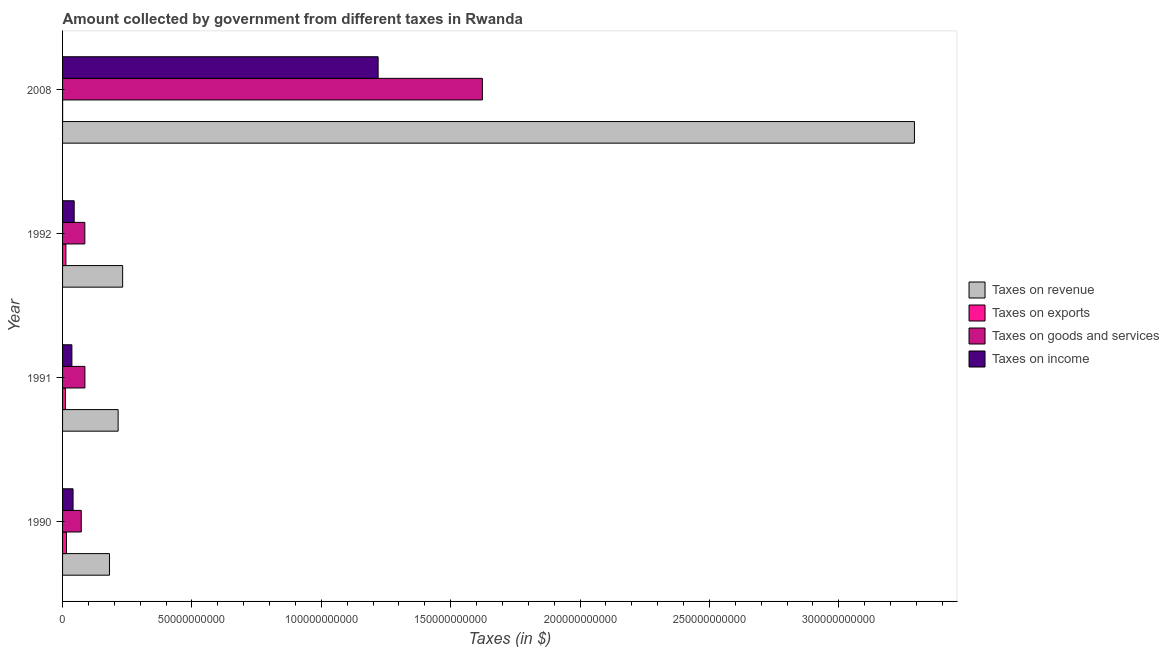Are the number of bars per tick equal to the number of legend labels?
Offer a very short reply. Yes. How many bars are there on the 4th tick from the top?
Offer a terse response. 4. In how many cases, is the number of bars for a given year not equal to the number of legend labels?
Give a very brief answer. 0. What is the amount collected as tax on income in 2008?
Make the answer very short. 1.22e+11. Across all years, what is the maximum amount collected as tax on exports?
Provide a succinct answer. 1.51e+09. Across all years, what is the minimum amount collected as tax on goods?
Give a very brief answer. 7.23e+09. What is the total amount collected as tax on exports in the graph?
Make the answer very short. 3.92e+09. What is the difference between the amount collected as tax on goods in 1991 and that in 2008?
Ensure brevity in your answer.  -1.54e+11. What is the difference between the amount collected as tax on revenue in 1991 and the amount collected as tax on goods in 2008?
Offer a very short reply. -1.41e+11. What is the average amount collected as tax on goods per year?
Ensure brevity in your answer.  4.67e+1. In the year 1991, what is the difference between the amount collected as tax on goods and amount collected as tax on income?
Provide a short and direct response. 5.03e+09. What is the ratio of the amount collected as tax on revenue in 1992 to that in 2008?
Provide a short and direct response. 0.07. Is the amount collected as tax on income in 1991 less than that in 1992?
Your response must be concise. Yes. What is the difference between the highest and the second highest amount collected as tax on exports?
Keep it short and to the point. 2.14e+08. What is the difference between the highest and the lowest amount collected as tax on exports?
Offer a terse response. 1.49e+09. Is the sum of the amount collected as tax on revenue in 1991 and 1992 greater than the maximum amount collected as tax on exports across all years?
Your response must be concise. Yes. What does the 2nd bar from the top in 2008 represents?
Ensure brevity in your answer.  Taxes on goods and services. What does the 3rd bar from the bottom in 1992 represents?
Your answer should be very brief. Taxes on goods and services. Is it the case that in every year, the sum of the amount collected as tax on revenue and amount collected as tax on exports is greater than the amount collected as tax on goods?
Keep it short and to the point. Yes. How many bars are there?
Provide a short and direct response. 16. What is the difference between two consecutive major ticks on the X-axis?
Provide a short and direct response. 5.00e+1. Are the values on the major ticks of X-axis written in scientific E-notation?
Provide a short and direct response. No. Does the graph contain any zero values?
Provide a succinct answer. No. How are the legend labels stacked?
Offer a terse response. Vertical. What is the title of the graph?
Offer a terse response. Amount collected by government from different taxes in Rwanda. Does "Grants and Revenue" appear as one of the legend labels in the graph?
Make the answer very short. No. What is the label or title of the X-axis?
Provide a succinct answer. Taxes (in $). What is the label or title of the Y-axis?
Ensure brevity in your answer.  Year. What is the Taxes (in $) of Taxes on revenue in 1990?
Provide a short and direct response. 1.81e+1. What is the Taxes (in $) in Taxes on exports in 1990?
Give a very brief answer. 1.51e+09. What is the Taxes (in $) in Taxes on goods and services in 1990?
Provide a short and direct response. 7.23e+09. What is the Taxes (in $) of Taxes on income in 1990?
Provide a succinct answer. 4.06e+09. What is the Taxes (in $) of Taxes on revenue in 1991?
Your answer should be very brief. 2.15e+1. What is the Taxes (in $) of Taxes on exports in 1991?
Provide a short and direct response. 1.11e+09. What is the Taxes (in $) in Taxes on goods and services in 1991?
Keep it short and to the point. 8.63e+09. What is the Taxes (in $) in Taxes on income in 1991?
Your answer should be very brief. 3.60e+09. What is the Taxes (in $) in Taxes on revenue in 1992?
Give a very brief answer. 2.32e+1. What is the Taxes (in $) in Taxes on exports in 1992?
Your answer should be compact. 1.29e+09. What is the Taxes (in $) in Taxes on goods and services in 1992?
Your answer should be very brief. 8.60e+09. What is the Taxes (in $) of Taxes on income in 1992?
Your response must be concise. 4.49e+09. What is the Taxes (in $) in Taxes on revenue in 2008?
Keep it short and to the point. 3.29e+11. What is the Taxes (in $) in Taxes on exports in 2008?
Give a very brief answer. 1.73e+07. What is the Taxes (in $) of Taxes on goods and services in 2008?
Your response must be concise. 1.62e+11. What is the Taxes (in $) of Taxes on income in 2008?
Provide a succinct answer. 1.22e+11. Across all years, what is the maximum Taxes (in $) of Taxes on revenue?
Provide a succinct answer. 3.29e+11. Across all years, what is the maximum Taxes (in $) of Taxes on exports?
Provide a succinct answer. 1.51e+09. Across all years, what is the maximum Taxes (in $) in Taxes on goods and services?
Keep it short and to the point. 1.62e+11. Across all years, what is the maximum Taxes (in $) in Taxes on income?
Offer a terse response. 1.22e+11. Across all years, what is the minimum Taxes (in $) in Taxes on revenue?
Your answer should be compact. 1.81e+1. Across all years, what is the minimum Taxes (in $) in Taxes on exports?
Ensure brevity in your answer.  1.73e+07. Across all years, what is the minimum Taxes (in $) of Taxes on goods and services?
Keep it short and to the point. 7.23e+09. Across all years, what is the minimum Taxes (in $) of Taxes on income?
Offer a very short reply. 3.60e+09. What is the total Taxes (in $) in Taxes on revenue in the graph?
Your answer should be compact. 3.92e+11. What is the total Taxes (in $) of Taxes on exports in the graph?
Offer a terse response. 3.92e+09. What is the total Taxes (in $) in Taxes on goods and services in the graph?
Make the answer very short. 1.87e+11. What is the total Taxes (in $) of Taxes on income in the graph?
Offer a terse response. 1.34e+11. What is the difference between the Taxes (in $) in Taxes on revenue in 1990 and that in 1991?
Your answer should be very brief. -3.34e+09. What is the difference between the Taxes (in $) in Taxes on exports in 1990 and that in 1991?
Offer a very short reply. 3.99e+08. What is the difference between the Taxes (in $) in Taxes on goods and services in 1990 and that in 1991?
Make the answer very short. -1.40e+09. What is the difference between the Taxes (in $) of Taxes on income in 1990 and that in 1991?
Offer a very short reply. 4.54e+08. What is the difference between the Taxes (in $) in Taxes on revenue in 1990 and that in 1992?
Provide a short and direct response. -5.09e+09. What is the difference between the Taxes (in $) in Taxes on exports in 1990 and that in 1992?
Offer a terse response. 2.14e+08. What is the difference between the Taxes (in $) in Taxes on goods and services in 1990 and that in 1992?
Provide a succinct answer. -1.38e+09. What is the difference between the Taxes (in $) of Taxes on income in 1990 and that in 1992?
Your answer should be compact. -4.31e+08. What is the difference between the Taxes (in $) of Taxes on revenue in 1990 and that in 2008?
Give a very brief answer. -3.11e+11. What is the difference between the Taxes (in $) in Taxes on exports in 1990 and that in 2008?
Your answer should be very brief. 1.49e+09. What is the difference between the Taxes (in $) of Taxes on goods and services in 1990 and that in 2008?
Offer a terse response. -1.55e+11. What is the difference between the Taxes (in $) in Taxes on income in 1990 and that in 2008?
Make the answer very short. -1.18e+11. What is the difference between the Taxes (in $) in Taxes on revenue in 1991 and that in 1992?
Your answer should be very brief. -1.75e+09. What is the difference between the Taxes (in $) in Taxes on exports in 1991 and that in 1992?
Your answer should be compact. -1.85e+08. What is the difference between the Taxes (in $) of Taxes on goods and services in 1991 and that in 1992?
Make the answer very short. 2.90e+07. What is the difference between the Taxes (in $) in Taxes on income in 1991 and that in 1992?
Make the answer very short. -8.85e+08. What is the difference between the Taxes (in $) in Taxes on revenue in 1991 and that in 2008?
Provide a short and direct response. -3.08e+11. What is the difference between the Taxes (in $) in Taxes on exports in 1991 and that in 2008?
Provide a succinct answer. 1.09e+09. What is the difference between the Taxes (in $) in Taxes on goods and services in 1991 and that in 2008?
Make the answer very short. -1.54e+11. What is the difference between the Taxes (in $) of Taxes on income in 1991 and that in 2008?
Ensure brevity in your answer.  -1.18e+11. What is the difference between the Taxes (in $) in Taxes on revenue in 1992 and that in 2008?
Ensure brevity in your answer.  -3.06e+11. What is the difference between the Taxes (in $) in Taxes on exports in 1992 and that in 2008?
Ensure brevity in your answer.  1.27e+09. What is the difference between the Taxes (in $) of Taxes on goods and services in 1992 and that in 2008?
Keep it short and to the point. -1.54e+11. What is the difference between the Taxes (in $) in Taxes on income in 1992 and that in 2008?
Keep it short and to the point. -1.17e+11. What is the difference between the Taxes (in $) of Taxes on revenue in 1990 and the Taxes (in $) of Taxes on exports in 1991?
Your answer should be compact. 1.70e+1. What is the difference between the Taxes (in $) in Taxes on revenue in 1990 and the Taxes (in $) in Taxes on goods and services in 1991?
Your response must be concise. 9.50e+09. What is the difference between the Taxes (in $) in Taxes on revenue in 1990 and the Taxes (in $) in Taxes on income in 1991?
Ensure brevity in your answer.  1.45e+1. What is the difference between the Taxes (in $) in Taxes on exports in 1990 and the Taxes (in $) in Taxes on goods and services in 1991?
Your answer should be very brief. -7.13e+09. What is the difference between the Taxes (in $) in Taxes on exports in 1990 and the Taxes (in $) in Taxes on income in 1991?
Your answer should be very brief. -2.10e+09. What is the difference between the Taxes (in $) of Taxes on goods and services in 1990 and the Taxes (in $) of Taxes on income in 1991?
Provide a succinct answer. 3.63e+09. What is the difference between the Taxes (in $) of Taxes on revenue in 1990 and the Taxes (in $) of Taxes on exports in 1992?
Make the answer very short. 1.68e+1. What is the difference between the Taxes (in $) of Taxes on revenue in 1990 and the Taxes (in $) of Taxes on goods and services in 1992?
Provide a succinct answer. 9.52e+09. What is the difference between the Taxes (in $) of Taxes on revenue in 1990 and the Taxes (in $) of Taxes on income in 1992?
Your answer should be very brief. 1.36e+1. What is the difference between the Taxes (in $) of Taxes on exports in 1990 and the Taxes (in $) of Taxes on goods and services in 1992?
Give a very brief answer. -7.10e+09. What is the difference between the Taxes (in $) in Taxes on exports in 1990 and the Taxes (in $) in Taxes on income in 1992?
Your answer should be very brief. -2.98e+09. What is the difference between the Taxes (in $) of Taxes on goods and services in 1990 and the Taxes (in $) of Taxes on income in 1992?
Keep it short and to the point. 2.74e+09. What is the difference between the Taxes (in $) in Taxes on revenue in 1990 and the Taxes (in $) in Taxes on exports in 2008?
Ensure brevity in your answer.  1.81e+1. What is the difference between the Taxes (in $) in Taxes on revenue in 1990 and the Taxes (in $) in Taxes on goods and services in 2008?
Provide a succinct answer. -1.44e+11. What is the difference between the Taxes (in $) of Taxes on revenue in 1990 and the Taxes (in $) of Taxes on income in 2008?
Provide a short and direct response. -1.04e+11. What is the difference between the Taxes (in $) of Taxes on exports in 1990 and the Taxes (in $) of Taxes on goods and services in 2008?
Keep it short and to the point. -1.61e+11. What is the difference between the Taxes (in $) of Taxes on exports in 1990 and the Taxes (in $) of Taxes on income in 2008?
Ensure brevity in your answer.  -1.20e+11. What is the difference between the Taxes (in $) in Taxes on goods and services in 1990 and the Taxes (in $) in Taxes on income in 2008?
Keep it short and to the point. -1.15e+11. What is the difference between the Taxes (in $) in Taxes on revenue in 1991 and the Taxes (in $) in Taxes on exports in 1992?
Your answer should be compact. 2.02e+1. What is the difference between the Taxes (in $) in Taxes on revenue in 1991 and the Taxes (in $) in Taxes on goods and services in 1992?
Make the answer very short. 1.29e+1. What is the difference between the Taxes (in $) of Taxes on revenue in 1991 and the Taxes (in $) of Taxes on income in 1992?
Offer a terse response. 1.70e+1. What is the difference between the Taxes (in $) of Taxes on exports in 1991 and the Taxes (in $) of Taxes on goods and services in 1992?
Your answer should be compact. -7.50e+09. What is the difference between the Taxes (in $) in Taxes on exports in 1991 and the Taxes (in $) in Taxes on income in 1992?
Keep it short and to the point. -3.38e+09. What is the difference between the Taxes (in $) in Taxes on goods and services in 1991 and the Taxes (in $) in Taxes on income in 1992?
Offer a very short reply. 4.14e+09. What is the difference between the Taxes (in $) of Taxes on revenue in 1991 and the Taxes (in $) of Taxes on exports in 2008?
Your answer should be very brief. 2.15e+1. What is the difference between the Taxes (in $) in Taxes on revenue in 1991 and the Taxes (in $) in Taxes on goods and services in 2008?
Offer a very short reply. -1.41e+11. What is the difference between the Taxes (in $) in Taxes on revenue in 1991 and the Taxes (in $) in Taxes on income in 2008?
Ensure brevity in your answer.  -1.00e+11. What is the difference between the Taxes (in $) in Taxes on exports in 1991 and the Taxes (in $) in Taxes on goods and services in 2008?
Keep it short and to the point. -1.61e+11. What is the difference between the Taxes (in $) of Taxes on exports in 1991 and the Taxes (in $) of Taxes on income in 2008?
Make the answer very short. -1.21e+11. What is the difference between the Taxes (in $) of Taxes on goods and services in 1991 and the Taxes (in $) of Taxes on income in 2008?
Keep it short and to the point. -1.13e+11. What is the difference between the Taxes (in $) in Taxes on revenue in 1992 and the Taxes (in $) in Taxes on exports in 2008?
Ensure brevity in your answer.  2.32e+1. What is the difference between the Taxes (in $) of Taxes on revenue in 1992 and the Taxes (in $) of Taxes on goods and services in 2008?
Offer a very short reply. -1.39e+11. What is the difference between the Taxes (in $) in Taxes on revenue in 1992 and the Taxes (in $) in Taxes on income in 2008?
Offer a terse response. -9.87e+1. What is the difference between the Taxes (in $) of Taxes on exports in 1992 and the Taxes (in $) of Taxes on goods and services in 2008?
Offer a very short reply. -1.61e+11. What is the difference between the Taxes (in $) of Taxes on exports in 1992 and the Taxes (in $) of Taxes on income in 2008?
Keep it short and to the point. -1.21e+11. What is the difference between the Taxes (in $) in Taxes on goods and services in 1992 and the Taxes (in $) in Taxes on income in 2008?
Provide a succinct answer. -1.13e+11. What is the average Taxes (in $) of Taxes on revenue per year?
Your answer should be very brief. 9.80e+1. What is the average Taxes (in $) of Taxes on exports per year?
Offer a terse response. 9.81e+08. What is the average Taxes (in $) in Taxes on goods and services per year?
Keep it short and to the point. 4.67e+1. What is the average Taxes (in $) in Taxes on income per year?
Keep it short and to the point. 3.35e+1. In the year 1990, what is the difference between the Taxes (in $) of Taxes on revenue and Taxes (in $) of Taxes on exports?
Give a very brief answer. 1.66e+1. In the year 1990, what is the difference between the Taxes (in $) in Taxes on revenue and Taxes (in $) in Taxes on goods and services?
Your answer should be very brief. 1.09e+1. In the year 1990, what is the difference between the Taxes (in $) in Taxes on revenue and Taxes (in $) in Taxes on income?
Provide a succinct answer. 1.41e+1. In the year 1990, what is the difference between the Taxes (in $) of Taxes on exports and Taxes (in $) of Taxes on goods and services?
Keep it short and to the point. -5.72e+09. In the year 1990, what is the difference between the Taxes (in $) in Taxes on exports and Taxes (in $) in Taxes on income?
Provide a succinct answer. -2.55e+09. In the year 1990, what is the difference between the Taxes (in $) in Taxes on goods and services and Taxes (in $) in Taxes on income?
Provide a succinct answer. 3.17e+09. In the year 1991, what is the difference between the Taxes (in $) of Taxes on revenue and Taxes (in $) of Taxes on exports?
Offer a very short reply. 2.04e+1. In the year 1991, what is the difference between the Taxes (in $) of Taxes on revenue and Taxes (in $) of Taxes on goods and services?
Provide a succinct answer. 1.28e+1. In the year 1991, what is the difference between the Taxes (in $) in Taxes on revenue and Taxes (in $) in Taxes on income?
Keep it short and to the point. 1.79e+1. In the year 1991, what is the difference between the Taxes (in $) of Taxes on exports and Taxes (in $) of Taxes on goods and services?
Offer a very short reply. -7.52e+09. In the year 1991, what is the difference between the Taxes (in $) of Taxes on exports and Taxes (in $) of Taxes on income?
Offer a very short reply. -2.50e+09. In the year 1991, what is the difference between the Taxes (in $) in Taxes on goods and services and Taxes (in $) in Taxes on income?
Offer a very short reply. 5.03e+09. In the year 1992, what is the difference between the Taxes (in $) in Taxes on revenue and Taxes (in $) in Taxes on exports?
Make the answer very short. 2.19e+1. In the year 1992, what is the difference between the Taxes (in $) in Taxes on revenue and Taxes (in $) in Taxes on goods and services?
Offer a very short reply. 1.46e+1. In the year 1992, what is the difference between the Taxes (in $) in Taxes on revenue and Taxes (in $) in Taxes on income?
Make the answer very short. 1.87e+1. In the year 1992, what is the difference between the Taxes (in $) of Taxes on exports and Taxes (in $) of Taxes on goods and services?
Offer a terse response. -7.31e+09. In the year 1992, what is the difference between the Taxes (in $) of Taxes on exports and Taxes (in $) of Taxes on income?
Make the answer very short. -3.20e+09. In the year 1992, what is the difference between the Taxes (in $) in Taxes on goods and services and Taxes (in $) in Taxes on income?
Provide a short and direct response. 4.12e+09. In the year 2008, what is the difference between the Taxes (in $) in Taxes on revenue and Taxes (in $) in Taxes on exports?
Offer a very short reply. 3.29e+11. In the year 2008, what is the difference between the Taxes (in $) of Taxes on revenue and Taxes (in $) of Taxes on goods and services?
Ensure brevity in your answer.  1.67e+11. In the year 2008, what is the difference between the Taxes (in $) of Taxes on revenue and Taxes (in $) of Taxes on income?
Give a very brief answer. 2.07e+11. In the year 2008, what is the difference between the Taxes (in $) of Taxes on exports and Taxes (in $) of Taxes on goods and services?
Your answer should be very brief. -1.62e+11. In the year 2008, what is the difference between the Taxes (in $) in Taxes on exports and Taxes (in $) in Taxes on income?
Offer a very short reply. -1.22e+11. In the year 2008, what is the difference between the Taxes (in $) of Taxes on goods and services and Taxes (in $) of Taxes on income?
Give a very brief answer. 4.03e+1. What is the ratio of the Taxes (in $) in Taxes on revenue in 1990 to that in 1991?
Keep it short and to the point. 0.84. What is the ratio of the Taxes (in $) in Taxes on exports in 1990 to that in 1991?
Keep it short and to the point. 1.36. What is the ratio of the Taxes (in $) in Taxes on goods and services in 1990 to that in 1991?
Make the answer very short. 0.84. What is the ratio of the Taxes (in $) in Taxes on income in 1990 to that in 1991?
Make the answer very short. 1.13. What is the ratio of the Taxes (in $) in Taxes on revenue in 1990 to that in 1992?
Make the answer very short. 0.78. What is the ratio of the Taxes (in $) of Taxes on exports in 1990 to that in 1992?
Your answer should be very brief. 1.17. What is the ratio of the Taxes (in $) in Taxes on goods and services in 1990 to that in 1992?
Provide a short and direct response. 0.84. What is the ratio of the Taxes (in $) of Taxes on income in 1990 to that in 1992?
Your response must be concise. 0.9. What is the ratio of the Taxes (in $) in Taxes on revenue in 1990 to that in 2008?
Your response must be concise. 0.06. What is the ratio of the Taxes (in $) of Taxes on exports in 1990 to that in 2008?
Your response must be concise. 87.09. What is the ratio of the Taxes (in $) in Taxes on goods and services in 1990 to that in 2008?
Make the answer very short. 0.04. What is the ratio of the Taxes (in $) in Taxes on revenue in 1991 to that in 1992?
Give a very brief answer. 0.92. What is the ratio of the Taxes (in $) in Taxes on exports in 1991 to that in 1992?
Keep it short and to the point. 0.86. What is the ratio of the Taxes (in $) of Taxes on goods and services in 1991 to that in 1992?
Make the answer very short. 1. What is the ratio of the Taxes (in $) in Taxes on income in 1991 to that in 1992?
Provide a succinct answer. 0.8. What is the ratio of the Taxes (in $) of Taxes on revenue in 1991 to that in 2008?
Give a very brief answer. 0.07. What is the ratio of the Taxes (in $) in Taxes on exports in 1991 to that in 2008?
Make the answer very short. 64.02. What is the ratio of the Taxes (in $) of Taxes on goods and services in 1991 to that in 2008?
Provide a succinct answer. 0.05. What is the ratio of the Taxes (in $) of Taxes on income in 1991 to that in 2008?
Your answer should be very brief. 0.03. What is the ratio of the Taxes (in $) of Taxes on revenue in 1992 to that in 2008?
Your answer should be compact. 0.07. What is the ratio of the Taxes (in $) in Taxes on exports in 1992 to that in 2008?
Make the answer very short. 74.72. What is the ratio of the Taxes (in $) in Taxes on goods and services in 1992 to that in 2008?
Your answer should be very brief. 0.05. What is the ratio of the Taxes (in $) of Taxes on income in 1992 to that in 2008?
Keep it short and to the point. 0.04. What is the difference between the highest and the second highest Taxes (in $) in Taxes on revenue?
Give a very brief answer. 3.06e+11. What is the difference between the highest and the second highest Taxes (in $) of Taxes on exports?
Provide a short and direct response. 2.14e+08. What is the difference between the highest and the second highest Taxes (in $) in Taxes on goods and services?
Offer a terse response. 1.54e+11. What is the difference between the highest and the second highest Taxes (in $) of Taxes on income?
Your answer should be very brief. 1.17e+11. What is the difference between the highest and the lowest Taxes (in $) of Taxes on revenue?
Your answer should be very brief. 3.11e+11. What is the difference between the highest and the lowest Taxes (in $) of Taxes on exports?
Offer a very short reply. 1.49e+09. What is the difference between the highest and the lowest Taxes (in $) in Taxes on goods and services?
Make the answer very short. 1.55e+11. What is the difference between the highest and the lowest Taxes (in $) in Taxes on income?
Make the answer very short. 1.18e+11. 